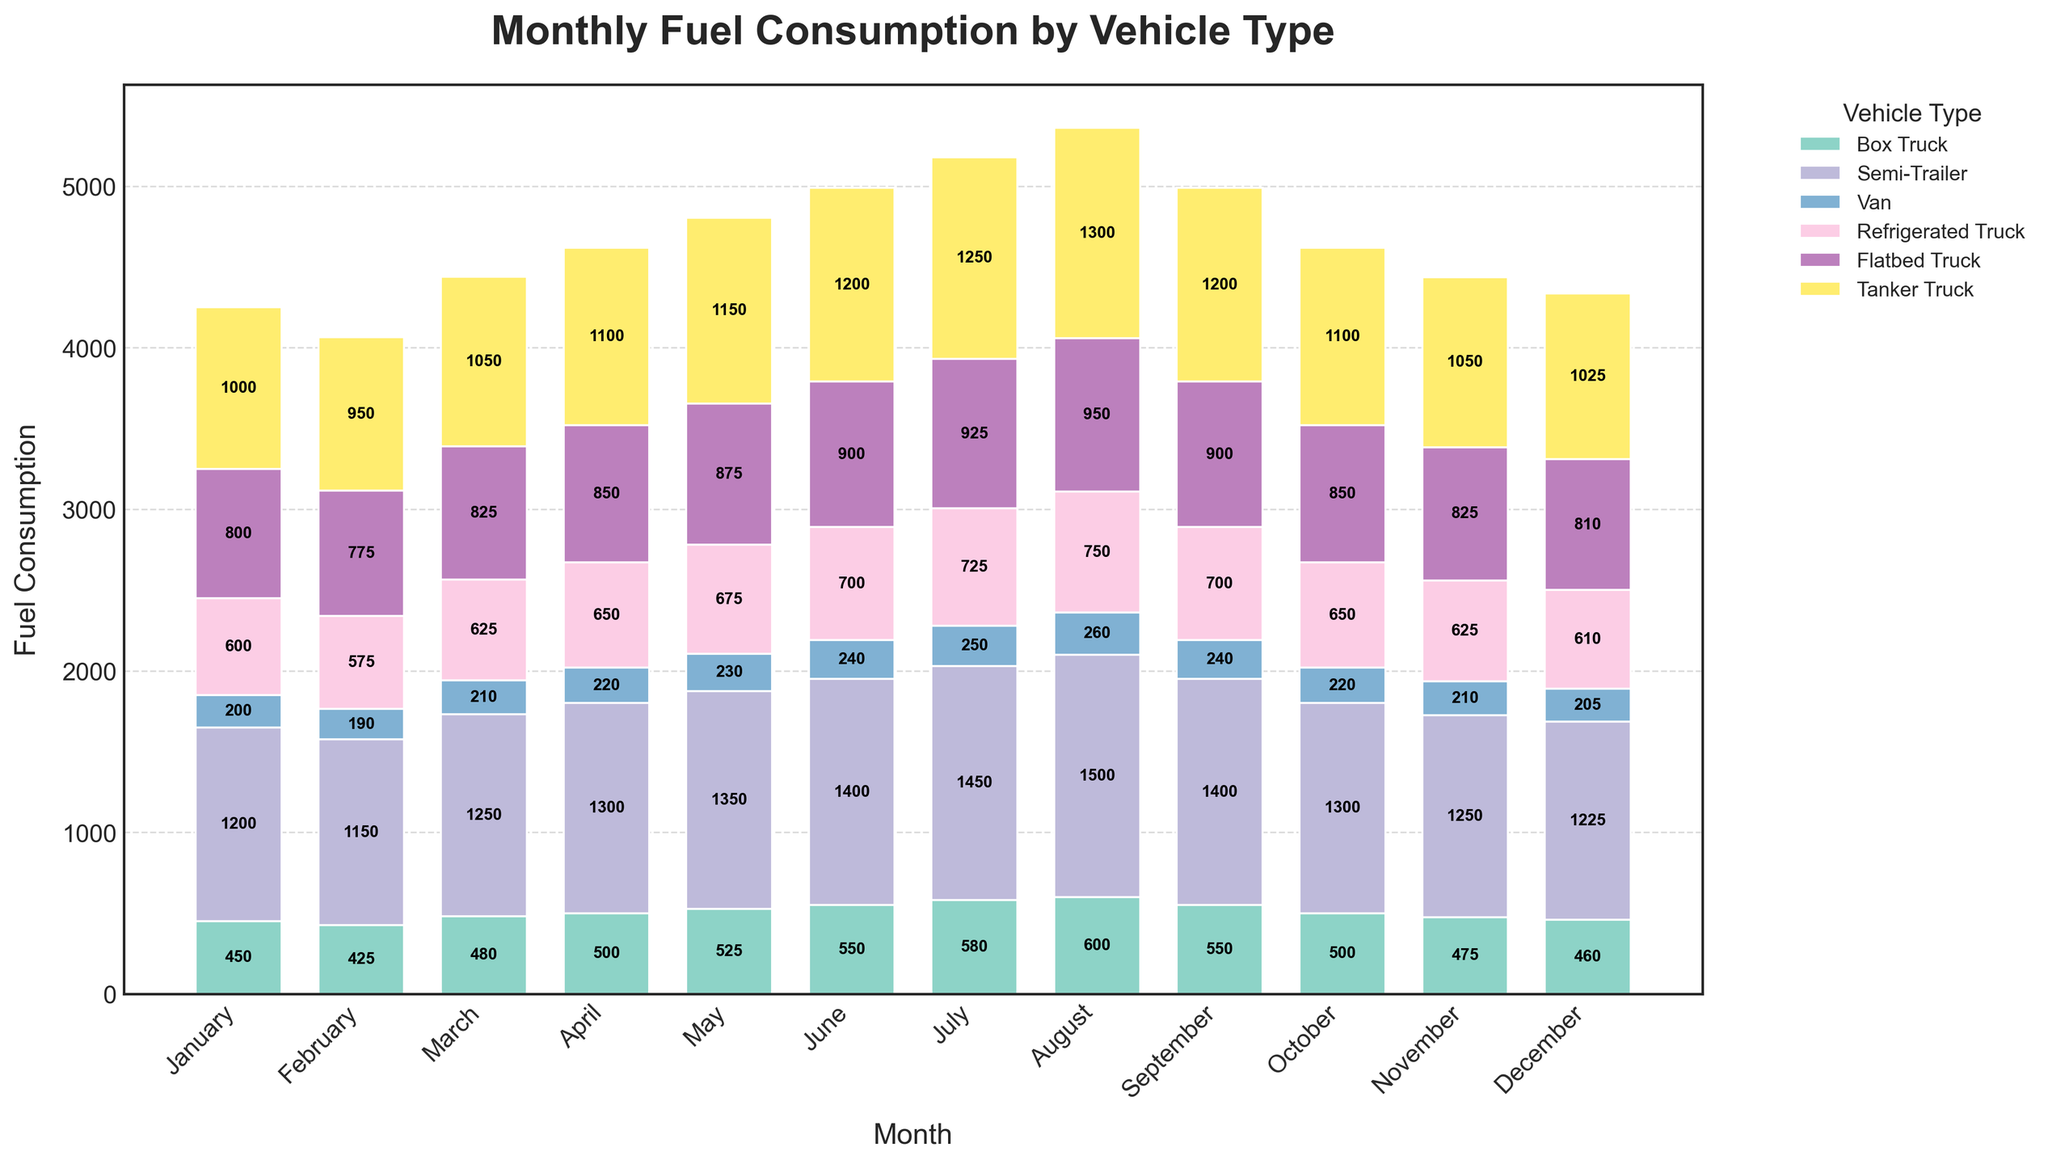Which vehicle type consumed the most fuel in July? Look at the bar heights for July across all vehicle types. The Semi-Trailer has the highest bar, indicating it's the type that consumed the most fuel in July.
Answer: Semi-Trailer Between Box Truck and Tanker Truck, which consumed more fuel in December? Compare the heights of the bars for Box Truck and Tanker Truck in December. The Tanker Truck's bar is higher, meaning it consumed more fuel.
Answer: Tanker Truck What is the total fuel consumption for all vehicle types in April? Sum the bar heights for April across all vehicle types (500 for Box Truck, 1300 for Semi-Trailer, 220 for Van, 650 for Refrigerated Truck, 850 for Flatbed Truck, and 1100 for Tanker Truck): 500 + 1300 + 220 + 650 + 850 + 1100 = 4620.
Answer: 4620 Which vehicle type saw the most consistent monthly fuel consumption? Evaluate the variability in bar heights across months for each vehicle type. The Van's bars are relatively close in height, indicating consistent fuel consumption.
Answer: Van What's the average monthly fuel consumption for Semi-Trailers throughout the year? Add up the monthly fuel values for Semi-Trailers (1200 + 1150 + 1250 + 1300 + 1350 + 1400 + 1450 + 1500 + 1400 + 1300 + 1250 + 1225 = 16075) and divide by 12 (total months): 16075 / 12 ≈ 1340.
Answer: 1340 How does the fuel consumption of Refrigerated Trucks in May compare to Flatbed Trucks? Compare the bar heights for Refrigerated Trucks (675) and Flatbed Trucks (875) in May. The Flatbed Truck consumed more fuel.
Answer: Flatbed Truck Which month shows the highest total fuel consumption across all vehicle types? Calculate the total fuel consumption for each month by summing the bar heights. August has the highest total (600 + 1500 + 260 + 750 + 950 + 1300 = 5360).
Answer: August For the month of October, list the vehicle types from highest to lowest fuel consumption. Refer to the bar heights for October and list the vehicle types in descending order: Semi-Trailer (1300), Tanker Truck (1100), Flatbed Truck (850), Box Truck (500), Refrigerated Truck (650), and Van (220).
Answer: Semi-Trailer, Tanker Truck, Flatbed Truck, Refrigerated Truck, Box Truck, Van 